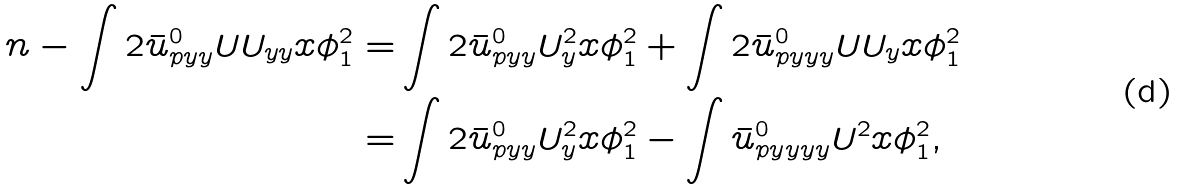Convert formula to latex. <formula><loc_0><loc_0><loc_500><loc_500>\ n - \int 2 \bar { u } ^ { 0 } _ { p y y } U U _ { y y } x \phi _ { 1 } ^ { 2 } = & \int 2 \bar { u } ^ { 0 } _ { p y y } U _ { y } ^ { 2 } x \phi _ { 1 } ^ { 2 } + \int 2 \bar { u } ^ { 0 } _ { p y y y } U U _ { y } x \phi _ { 1 } ^ { 2 } \\ = & \int 2 \bar { u } ^ { 0 } _ { p y y } U _ { y } ^ { 2 } x \phi _ { 1 } ^ { 2 } - \int \bar { u } ^ { 0 } _ { p y y y y } U ^ { 2 } x \phi _ { 1 } ^ { 2 } ,</formula> 